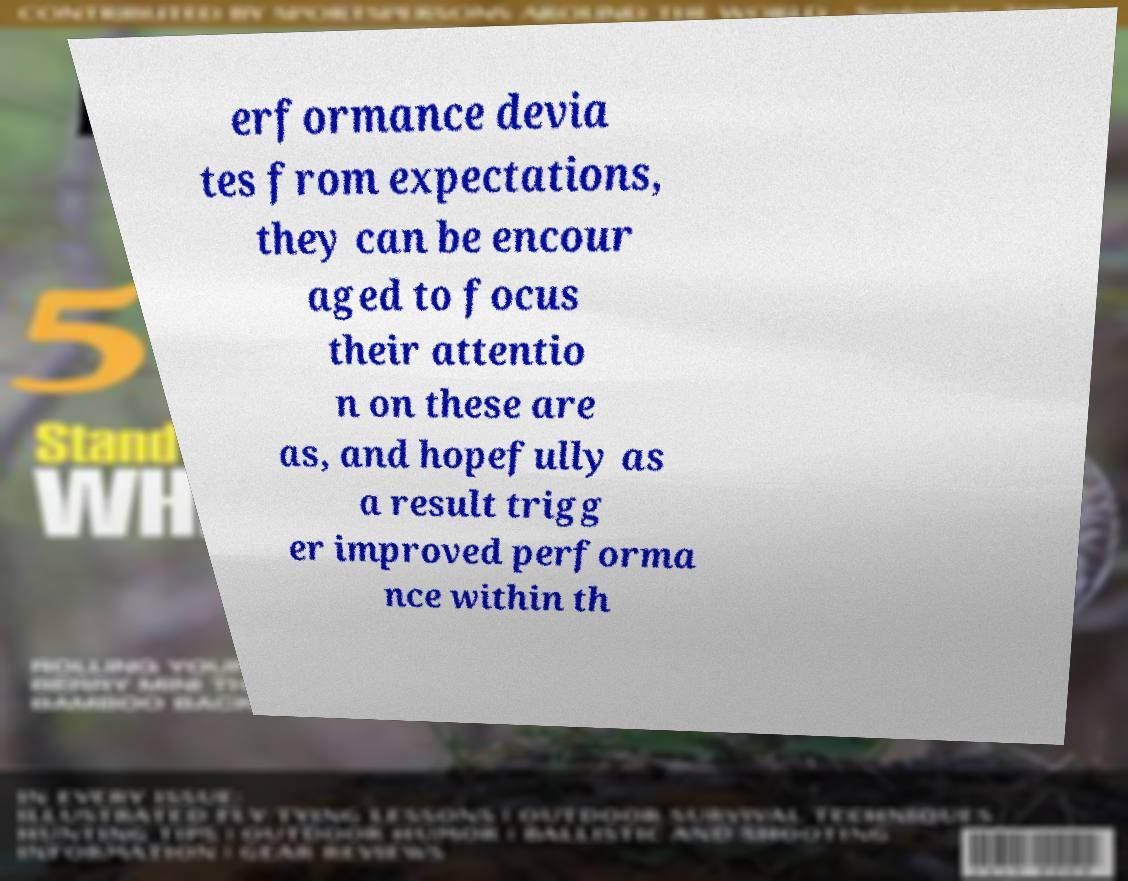Please read and relay the text visible in this image. What does it say? erformance devia tes from expectations, they can be encour aged to focus their attentio n on these are as, and hopefully as a result trigg er improved performa nce within th 